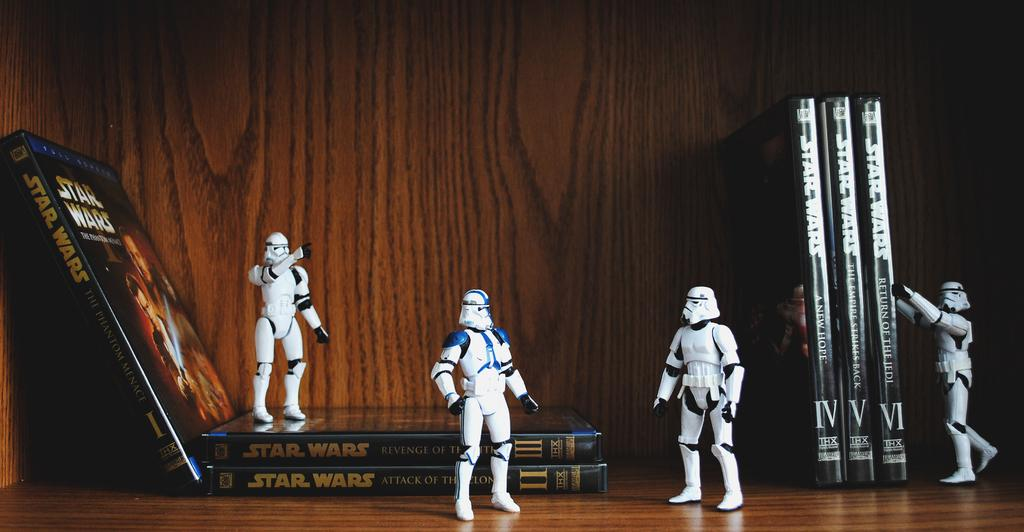What type of toys are present in the image? There are toy robots in the image. What else can be seen in the image besides the toy robots? There are books present in the image. On what surface are the objects placed? The objects are present on a wood surface. What can be seen in the background of the image? There is a wood wall visible in the background of the image. What type of grape is being used as a pail in the image? There is no grape or pail present in the image; it features toy robots and books on a wood surface with a wood wall in the background. 